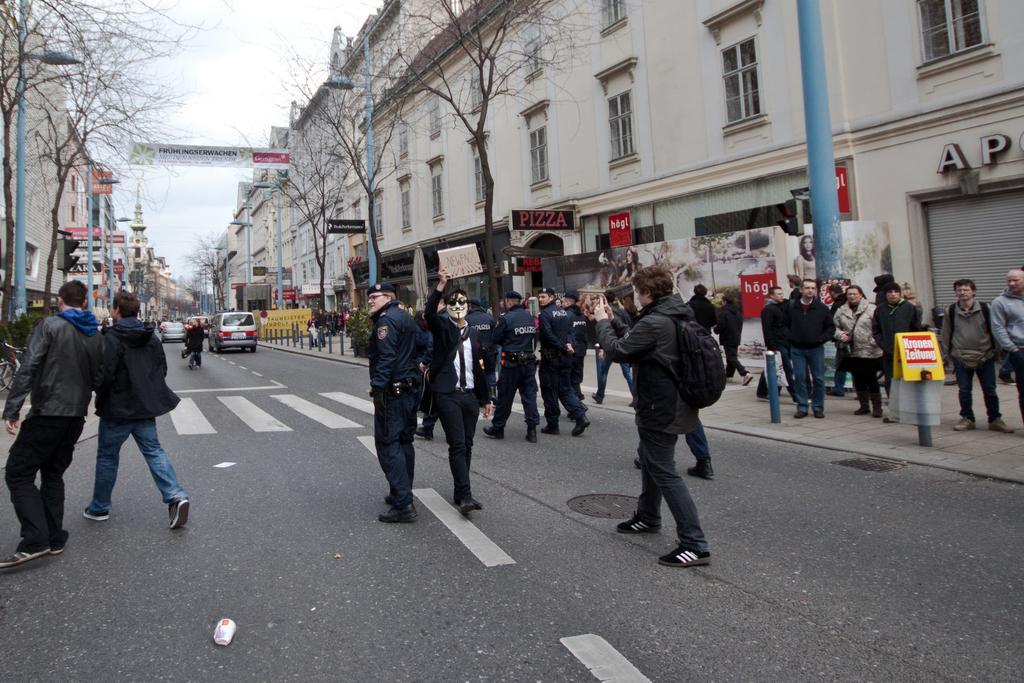Please provide a concise description of this image. In this image to the bottom there is a road, on the road there are some people who are walking and one person is wearing a mask and walking. On the right side there are some buildings, poles, trees and some boards. And on the left side there are some buildings, trees, poles and in the center there is a hoarding and a fence. 